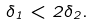Convert formula to latex. <formula><loc_0><loc_0><loc_500><loc_500>\delta _ { 1 } < 2 \delta _ { 2 } .</formula> 